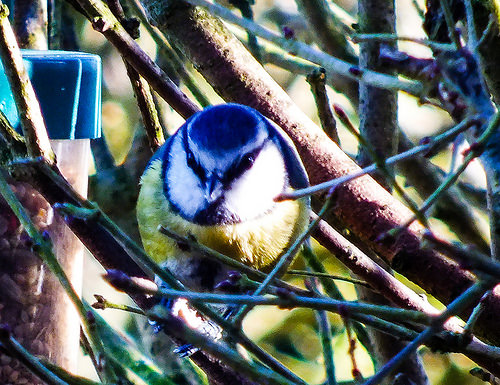<image>
Is the bird on the stem? No. The bird is not positioned on the stem. They may be near each other, but the bird is not supported by or resting on top of the stem. 